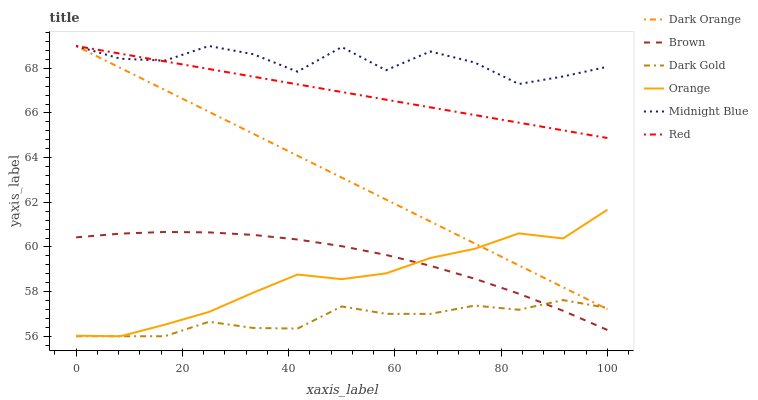Does Dark Gold have the minimum area under the curve?
Answer yes or no. Yes. Does Midnight Blue have the maximum area under the curve?
Answer yes or no. Yes. Does Brown have the minimum area under the curve?
Answer yes or no. No. Does Brown have the maximum area under the curve?
Answer yes or no. No. Is Dark Orange the smoothest?
Answer yes or no. Yes. Is Midnight Blue the roughest?
Answer yes or no. Yes. Is Brown the smoothest?
Answer yes or no. No. Is Brown the roughest?
Answer yes or no. No. Does Dark Gold have the lowest value?
Answer yes or no. Yes. Does Brown have the lowest value?
Answer yes or no. No. Does Red have the highest value?
Answer yes or no. Yes. Does Brown have the highest value?
Answer yes or no. No. Is Brown less than Dark Orange?
Answer yes or no. Yes. Is Midnight Blue greater than Dark Gold?
Answer yes or no. Yes. Does Dark Gold intersect Dark Orange?
Answer yes or no. Yes. Is Dark Gold less than Dark Orange?
Answer yes or no. No. Is Dark Gold greater than Dark Orange?
Answer yes or no. No. Does Brown intersect Dark Orange?
Answer yes or no. No. 